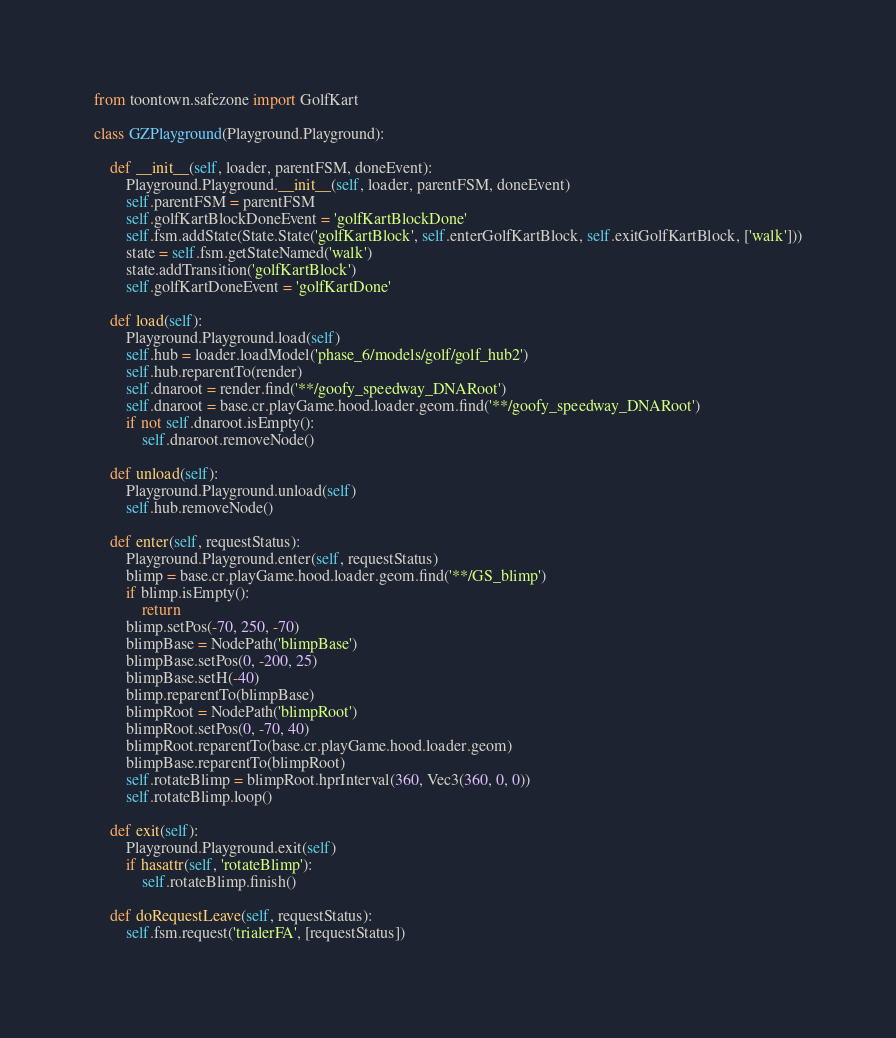<code> <loc_0><loc_0><loc_500><loc_500><_Python_>from toontown.safezone import GolfKart

class GZPlayground(Playground.Playground):

    def __init__(self, loader, parentFSM, doneEvent):
        Playground.Playground.__init__(self, loader, parentFSM, doneEvent)
        self.parentFSM = parentFSM
        self.golfKartBlockDoneEvent = 'golfKartBlockDone'
        self.fsm.addState(State.State('golfKartBlock', self.enterGolfKartBlock, self.exitGolfKartBlock, ['walk']))
        state = self.fsm.getStateNamed('walk')
        state.addTransition('golfKartBlock')
        self.golfKartDoneEvent = 'golfKartDone'

    def load(self):
        Playground.Playground.load(self)
        self.hub = loader.loadModel('phase_6/models/golf/golf_hub2')
        self.hub.reparentTo(render)
        self.dnaroot = render.find('**/goofy_speedway_DNARoot')
        self.dnaroot = base.cr.playGame.hood.loader.geom.find('**/goofy_speedway_DNARoot')
        if not self.dnaroot.isEmpty():
            self.dnaroot.removeNode()

    def unload(self):
        Playground.Playground.unload(self)
        self.hub.removeNode()

    def enter(self, requestStatus):
        Playground.Playground.enter(self, requestStatus)
        blimp = base.cr.playGame.hood.loader.geom.find('**/GS_blimp')
        if blimp.isEmpty():
            return
        blimp.setPos(-70, 250, -70)
        blimpBase = NodePath('blimpBase')
        blimpBase.setPos(0, -200, 25)
        blimpBase.setH(-40)
        blimp.reparentTo(blimpBase)
        blimpRoot = NodePath('blimpRoot')
        blimpRoot.setPos(0, -70, 40)
        blimpRoot.reparentTo(base.cr.playGame.hood.loader.geom)
        blimpBase.reparentTo(blimpRoot)
        self.rotateBlimp = blimpRoot.hprInterval(360, Vec3(360, 0, 0))
        self.rotateBlimp.loop()

    def exit(self):
        Playground.Playground.exit(self)
        if hasattr(self, 'rotateBlimp'):
            self.rotateBlimp.finish()

    def doRequestLeave(self, requestStatus):
        self.fsm.request('trialerFA', [requestStatus])
</code> 